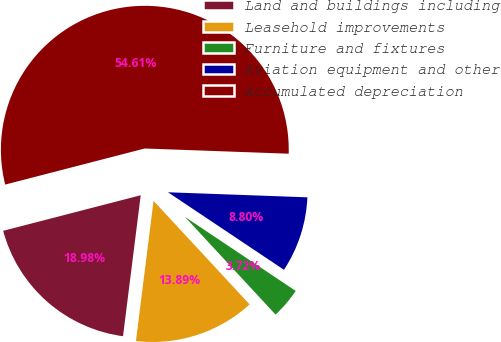<chart> <loc_0><loc_0><loc_500><loc_500><pie_chart><fcel>Land and buildings including<fcel>Leasehold improvements<fcel>Furniture and fixtures<fcel>Aviation equipment and other<fcel>Accumulated depreciation<nl><fcel>18.98%<fcel>13.89%<fcel>3.72%<fcel>8.8%<fcel>54.6%<nl></chart> 